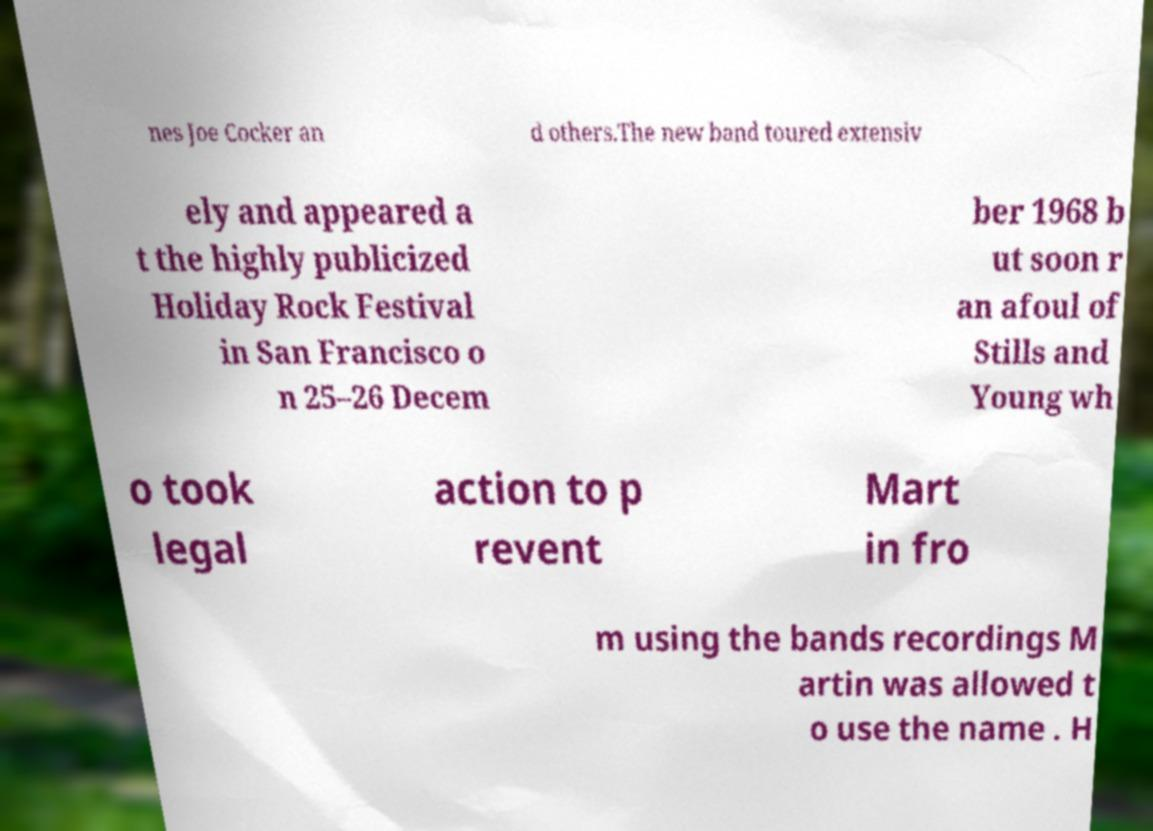Could you extract and type out the text from this image? nes Joe Cocker an d others.The new band toured extensiv ely and appeared a t the highly publicized Holiday Rock Festival in San Francisco o n 25–26 Decem ber 1968 b ut soon r an afoul of Stills and Young wh o took legal action to p revent Mart in fro m using the bands recordings M artin was allowed t o use the name . H 